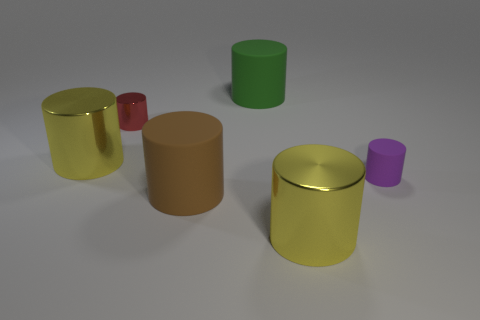What color is the other thing that is the same size as the purple thing?
Offer a terse response. Red. There is a big yellow shiny thing that is left of the big yellow object that is in front of the big brown cylinder; are there any purple matte cylinders behind it?
Offer a terse response. No. What is the large green cylinder that is on the left side of the small matte cylinder made of?
Provide a succinct answer. Rubber. There is a brown thing; is its shape the same as the big yellow shiny thing that is on the right side of the tiny red cylinder?
Provide a short and direct response. Yes. Is the number of tiny cylinders to the right of the brown cylinder the same as the number of purple matte cylinders in front of the tiny purple rubber cylinder?
Your response must be concise. No. What number of other things are there of the same material as the red cylinder
Keep it short and to the point. 2. What number of metal things are either small objects or cylinders?
Offer a very short reply. 3. There is a large thing on the right side of the big green matte cylinder; does it have the same shape as the tiny rubber object?
Offer a terse response. Yes. Are there more large yellow cylinders that are right of the small red shiny cylinder than large yellow things?
Provide a short and direct response. No. What number of large objects are both in front of the small metallic thing and right of the small red cylinder?
Offer a very short reply. 2. 